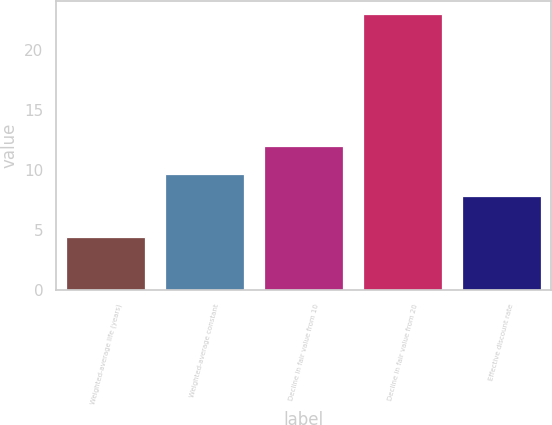<chart> <loc_0><loc_0><loc_500><loc_500><bar_chart><fcel>Weighted-average life (years)<fcel>Weighted-average constant<fcel>Decline in fair value from 10<fcel>Decline in fair value from 20<fcel>Effective discount rate<nl><fcel>4.4<fcel>9.67<fcel>12<fcel>23<fcel>7.81<nl></chart> 